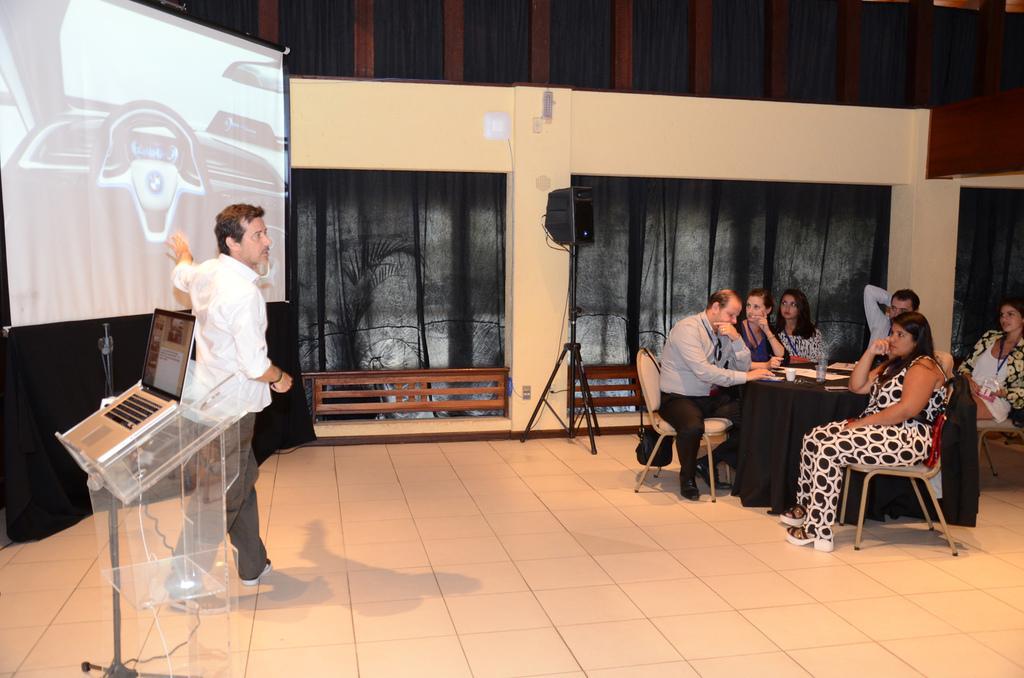How would you summarize this image in a sentence or two? This picture is of inside. On the right there are group of people sitting on the chairs and there is a glass and some papers placed on the top of the table. In the center there is a speaker attached to the stand. On the left there is a projector screen and a man wearing a white color shirt and standing and there is a table on the top of which a Laptop is placed. In the background there is a wall and curtains. 